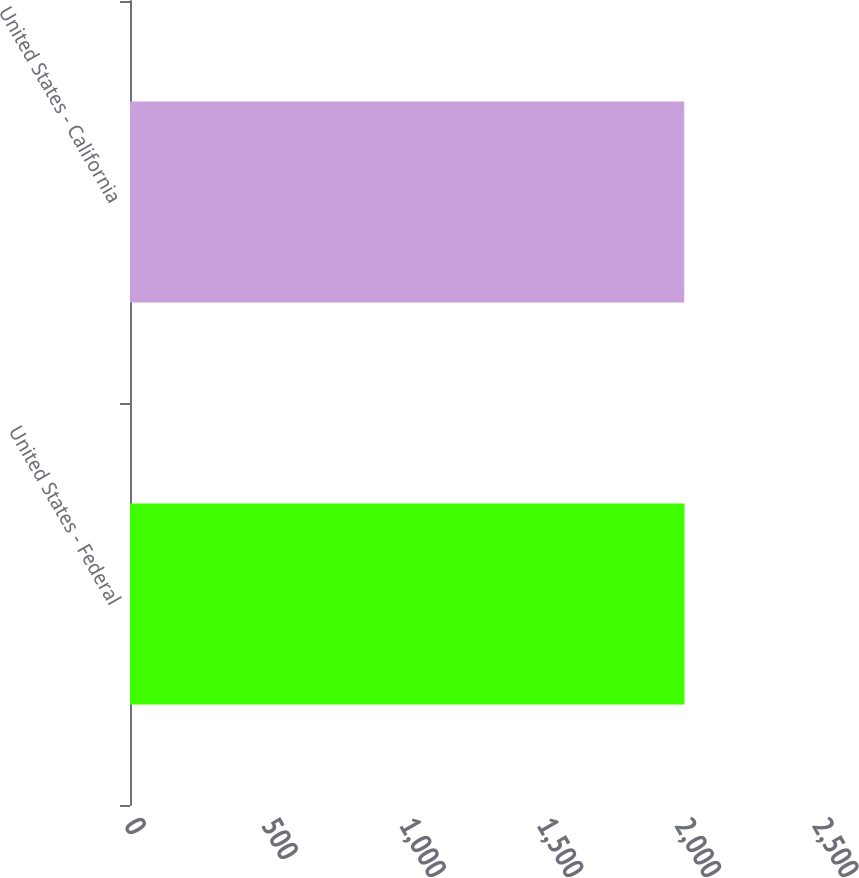Convert chart to OTSL. <chart><loc_0><loc_0><loc_500><loc_500><bar_chart><fcel>United States - Federal<fcel>United States - California<nl><fcel>2015<fcel>2014<nl></chart> 